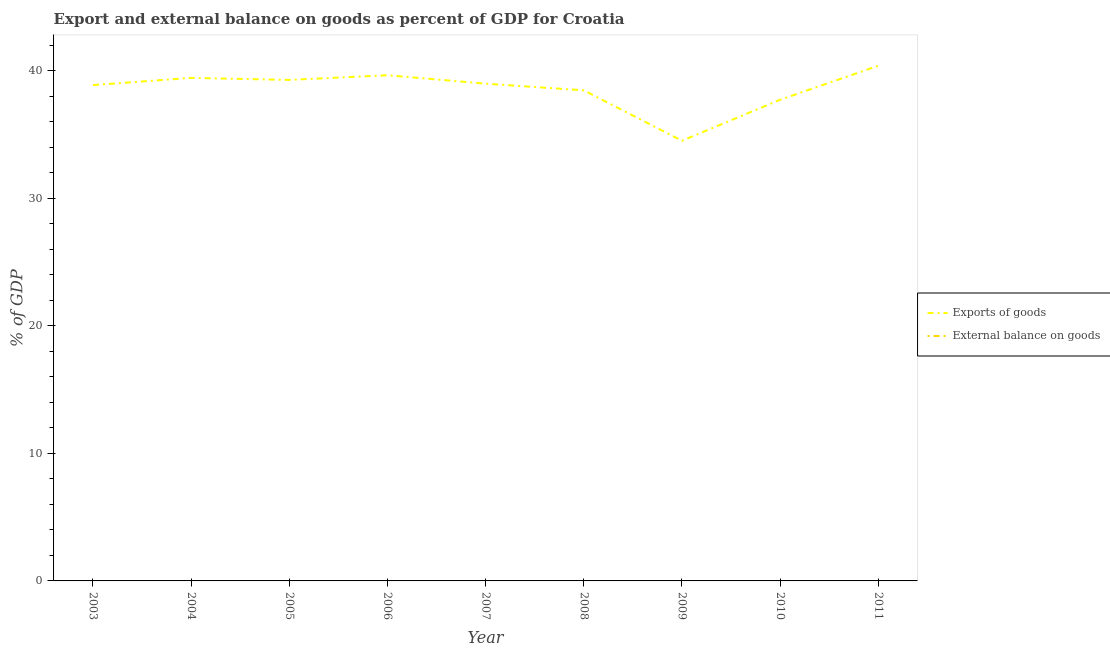Does the line corresponding to export of goods as percentage of gdp intersect with the line corresponding to external balance on goods as percentage of gdp?
Offer a very short reply. No. What is the external balance on goods as percentage of gdp in 2010?
Provide a short and direct response. 0. Across all years, what is the maximum export of goods as percentage of gdp?
Provide a short and direct response. 40.41. In which year was the export of goods as percentage of gdp maximum?
Give a very brief answer. 2011. What is the total external balance on goods as percentage of gdp in the graph?
Your answer should be very brief. 0. What is the difference between the export of goods as percentage of gdp in 2004 and that in 2008?
Your response must be concise. 0.98. What is the difference between the external balance on goods as percentage of gdp in 2004 and the export of goods as percentage of gdp in 2011?
Ensure brevity in your answer.  -40.41. What is the average export of goods as percentage of gdp per year?
Give a very brief answer. 38.61. What is the ratio of the export of goods as percentage of gdp in 2004 to that in 2009?
Your response must be concise. 1.14. What is the difference between the highest and the second highest export of goods as percentage of gdp?
Offer a very short reply. 0.74. What is the difference between the highest and the lowest export of goods as percentage of gdp?
Offer a terse response. 5.88. Is the sum of the export of goods as percentage of gdp in 2005 and 2006 greater than the maximum external balance on goods as percentage of gdp across all years?
Make the answer very short. Yes. Is the external balance on goods as percentage of gdp strictly less than the export of goods as percentage of gdp over the years?
Your answer should be compact. Yes. How many lines are there?
Your response must be concise. 1. How many years are there in the graph?
Keep it short and to the point. 9. Are the values on the major ticks of Y-axis written in scientific E-notation?
Give a very brief answer. No. How many legend labels are there?
Your answer should be very brief. 2. What is the title of the graph?
Offer a very short reply. Export and external balance on goods as percent of GDP for Croatia. Does "Residents" appear as one of the legend labels in the graph?
Your answer should be very brief. No. What is the label or title of the X-axis?
Offer a terse response. Year. What is the label or title of the Y-axis?
Your answer should be very brief. % of GDP. What is the % of GDP in Exports of goods in 2003?
Offer a very short reply. 38.89. What is the % of GDP of Exports of goods in 2004?
Offer a very short reply. 39.45. What is the % of GDP in Exports of goods in 2005?
Your answer should be very brief. 39.3. What is the % of GDP of Exports of goods in 2006?
Give a very brief answer. 39.66. What is the % of GDP in External balance on goods in 2006?
Keep it short and to the point. 0. What is the % of GDP of Exports of goods in 2007?
Provide a succinct answer. 39. What is the % of GDP of Exports of goods in 2008?
Offer a terse response. 38.48. What is the % of GDP in Exports of goods in 2009?
Your answer should be compact. 34.52. What is the % of GDP in Exports of goods in 2010?
Your answer should be very brief. 37.74. What is the % of GDP in External balance on goods in 2010?
Offer a terse response. 0. What is the % of GDP in Exports of goods in 2011?
Give a very brief answer. 40.41. Across all years, what is the maximum % of GDP of Exports of goods?
Provide a short and direct response. 40.41. Across all years, what is the minimum % of GDP in Exports of goods?
Ensure brevity in your answer.  34.52. What is the total % of GDP in Exports of goods in the graph?
Offer a terse response. 347.45. What is the difference between the % of GDP in Exports of goods in 2003 and that in 2004?
Offer a terse response. -0.56. What is the difference between the % of GDP in Exports of goods in 2003 and that in 2005?
Your answer should be very brief. -0.41. What is the difference between the % of GDP of Exports of goods in 2003 and that in 2006?
Provide a short and direct response. -0.77. What is the difference between the % of GDP in Exports of goods in 2003 and that in 2007?
Make the answer very short. -0.11. What is the difference between the % of GDP of Exports of goods in 2003 and that in 2008?
Give a very brief answer. 0.41. What is the difference between the % of GDP in Exports of goods in 2003 and that in 2009?
Your answer should be very brief. 4.37. What is the difference between the % of GDP of Exports of goods in 2003 and that in 2010?
Give a very brief answer. 1.15. What is the difference between the % of GDP in Exports of goods in 2003 and that in 2011?
Keep it short and to the point. -1.52. What is the difference between the % of GDP in Exports of goods in 2004 and that in 2005?
Keep it short and to the point. 0.16. What is the difference between the % of GDP of Exports of goods in 2004 and that in 2006?
Provide a succinct answer. -0.21. What is the difference between the % of GDP in Exports of goods in 2004 and that in 2007?
Your response must be concise. 0.45. What is the difference between the % of GDP in Exports of goods in 2004 and that in 2008?
Your response must be concise. 0.98. What is the difference between the % of GDP of Exports of goods in 2004 and that in 2009?
Ensure brevity in your answer.  4.93. What is the difference between the % of GDP in Exports of goods in 2004 and that in 2010?
Your answer should be very brief. 1.72. What is the difference between the % of GDP of Exports of goods in 2004 and that in 2011?
Ensure brevity in your answer.  -0.95. What is the difference between the % of GDP in Exports of goods in 2005 and that in 2006?
Give a very brief answer. -0.37. What is the difference between the % of GDP of Exports of goods in 2005 and that in 2007?
Your answer should be very brief. 0.29. What is the difference between the % of GDP of Exports of goods in 2005 and that in 2008?
Provide a short and direct response. 0.82. What is the difference between the % of GDP of Exports of goods in 2005 and that in 2009?
Offer a very short reply. 4.77. What is the difference between the % of GDP in Exports of goods in 2005 and that in 2010?
Give a very brief answer. 1.56. What is the difference between the % of GDP of Exports of goods in 2005 and that in 2011?
Your answer should be very brief. -1.11. What is the difference between the % of GDP in Exports of goods in 2006 and that in 2007?
Give a very brief answer. 0.66. What is the difference between the % of GDP of Exports of goods in 2006 and that in 2008?
Provide a short and direct response. 1.19. What is the difference between the % of GDP of Exports of goods in 2006 and that in 2009?
Your response must be concise. 5.14. What is the difference between the % of GDP in Exports of goods in 2006 and that in 2010?
Make the answer very short. 1.93. What is the difference between the % of GDP of Exports of goods in 2006 and that in 2011?
Provide a short and direct response. -0.74. What is the difference between the % of GDP in Exports of goods in 2007 and that in 2008?
Offer a terse response. 0.52. What is the difference between the % of GDP in Exports of goods in 2007 and that in 2009?
Offer a terse response. 4.48. What is the difference between the % of GDP of Exports of goods in 2007 and that in 2010?
Give a very brief answer. 1.26. What is the difference between the % of GDP in Exports of goods in 2007 and that in 2011?
Provide a succinct answer. -1.41. What is the difference between the % of GDP of Exports of goods in 2008 and that in 2009?
Give a very brief answer. 3.95. What is the difference between the % of GDP of Exports of goods in 2008 and that in 2010?
Keep it short and to the point. 0.74. What is the difference between the % of GDP of Exports of goods in 2008 and that in 2011?
Offer a very short reply. -1.93. What is the difference between the % of GDP in Exports of goods in 2009 and that in 2010?
Make the answer very short. -3.21. What is the difference between the % of GDP in Exports of goods in 2009 and that in 2011?
Your response must be concise. -5.88. What is the difference between the % of GDP of Exports of goods in 2010 and that in 2011?
Offer a very short reply. -2.67. What is the average % of GDP in Exports of goods per year?
Your response must be concise. 38.61. What is the average % of GDP of External balance on goods per year?
Give a very brief answer. 0. What is the ratio of the % of GDP in Exports of goods in 2003 to that in 2004?
Your answer should be compact. 0.99. What is the ratio of the % of GDP in Exports of goods in 2003 to that in 2006?
Your response must be concise. 0.98. What is the ratio of the % of GDP of Exports of goods in 2003 to that in 2007?
Give a very brief answer. 1. What is the ratio of the % of GDP in Exports of goods in 2003 to that in 2008?
Make the answer very short. 1.01. What is the ratio of the % of GDP of Exports of goods in 2003 to that in 2009?
Ensure brevity in your answer.  1.13. What is the ratio of the % of GDP in Exports of goods in 2003 to that in 2010?
Your answer should be compact. 1.03. What is the ratio of the % of GDP in Exports of goods in 2003 to that in 2011?
Give a very brief answer. 0.96. What is the ratio of the % of GDP of Exports of goods in 2004 to that in 2006?
Make the answer very short. 0.99. What is the ratio of the % of GDP of Exports of goods in 2004 to that in 2007?
Your response must be concise. 1.01. What is the ratio of the % of GDP of Exports of goods in 2004 to that in 2008?
Give a very brief answer. 1.03. What is the ratio of the % of GDP of Exports of goods in 2004 to that in 2009?
Give a very brief answer. 1.14. What is the ratio of the % of GDP of Exports of goods in 2004 to that in 2010?
Give a very brief answer. 1.05. What is the ratio of the % of GDP of Exports of goods in 2004 to that in 2011?
Keep it short and to the point. 0.98. What is the ratio of the % of GDP of Exports of goods in 2005 to that in 2006?
Keep it short and to the point. 0.99. What is the ratio of the % of GDP in Exports of goods in 2005 to that in 2007?
Offer a terse response. 1.01. What is the ratio of the % of GDP of Exports of goods in 2005 to that in 2008?
Your response must be concise. 1.02. What is the ratio of the % of GDP of Exports of goods in 2005 to that in 2009?
Your answer should be compact. 1.14. What is the ratio of the % of GDP in Exports of goods in 2005 to that in 2010?
Ensure brevity in your answer.  1.04. What is the ratio of the % of GDP in Exports of goods in 2005 to that in 2011?
Keep it short and to the point. 0.97. What is the ratio of the % of GDP in Exports of goods in 2006 to that in 2008?
Your answer should be very brief. 1.03. What is the ratio of the % of GDP in Exports of goods in 2006 to that in 2009?
Provide a short and direct response. 1.15. What is the ratio of the % of GDP in Exports of goods in 2006 to that in 2010?
Your response must be concise. 1.05. What is the ratio of the % of GDP in Exports of goods in 2006 to that in 2011?
Offer a very short reply. 0.98. What is the ratio of the % of GDP of Exports of goods in 2007 to that in 2008?
Keep it short and to the point. 1.01. What is the ratio of the % of GDP in Exports of goods in 2007 to that in 2009?
Your response must be concise. 1.13. What is the ratio of the % of GDP in Exports of goods in 2007 to that in 2010?
Provide a short and direct response. 1.03. What is the ratio of the % of GDP in Exports of goods in 2007 to that in 2011?
Provide a succinct answer. 0.97. What is the ratio of the % of GDP of Exports of goods in 2008 to that in 2009?
Provide a succinct answer. 1.11. What is the ratio of the % of GDP of Exports of goods in 2008 to that in 2010?
Your answer should be very brief. 1.02. What is the ratio of the % of GDP in Exports of goods in 2008 to that in 2011?
Offer a terse response. 0.95. What is the ratio of the % of GDP of Exports of goods in 2009 to that in 2010?
Ensure brevity in your answer.  0.91. What is the ratio of the % of GDP of Exports of goods in 2009 to that in 2011?
Your answer should be very brief. 0.85. What is the ratio of the % of GDP in Exports of goods in 2010 to that in 2011?
Provide a succinct answer. 0.93. What is the difference between the highest and the second highest % of GDP of Exports of goods?
Offer a very short reply. 0.74. What is the difference between the highest and the lowest % of GDP of Exports of goods?
Your answer should be very brief. 5.88. 